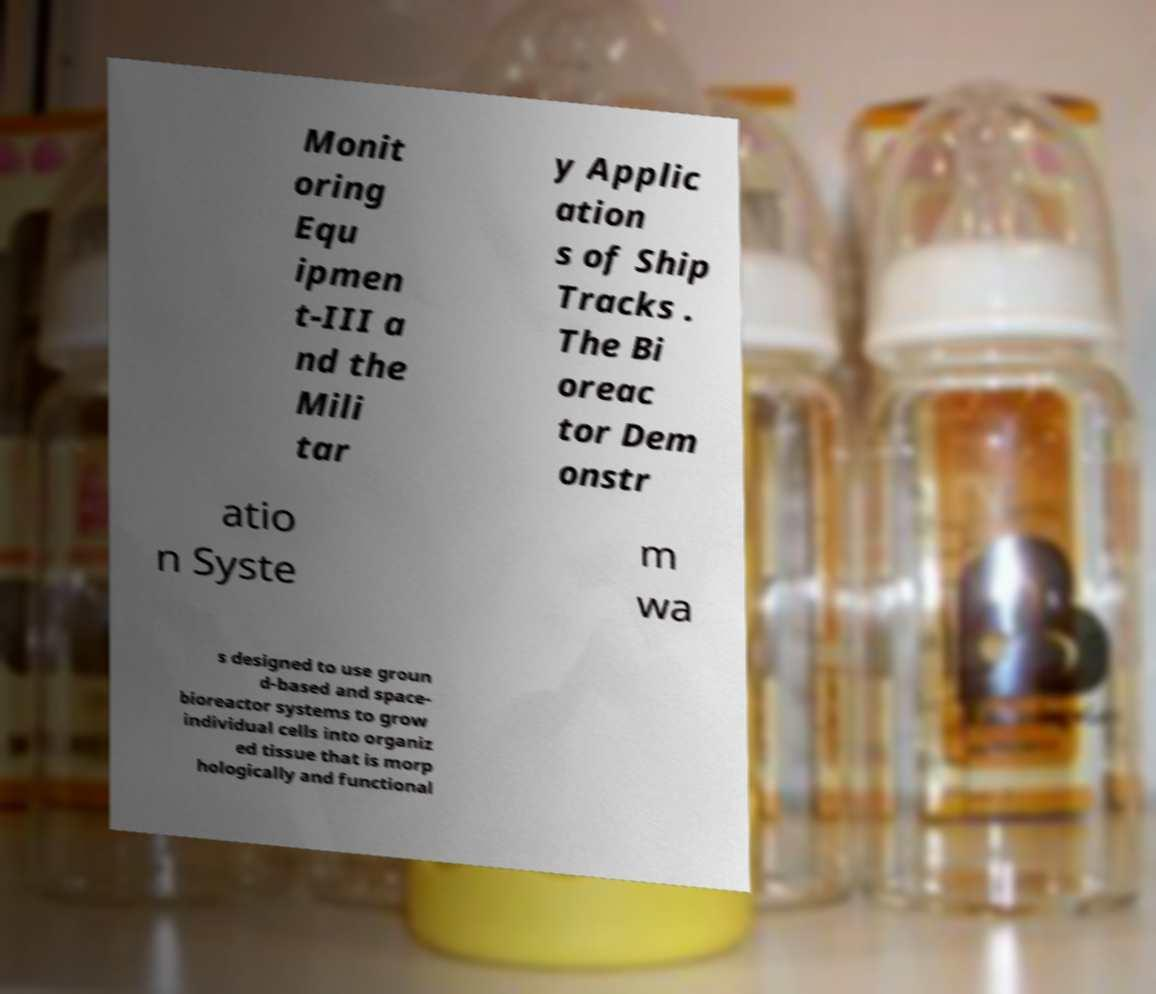I need the written content from this picture converted into text. Can you do that? Monit oring Equ ipmen t-III a nd the Mili tar y Applic ation s of Ship Tracks . The Bi oreac tor Dem onstr atio n Syste m wa s designed to use groun d-based and space- bioreactor systems to grow individual cells into organiz ed tissue that is morp hologically and functional 